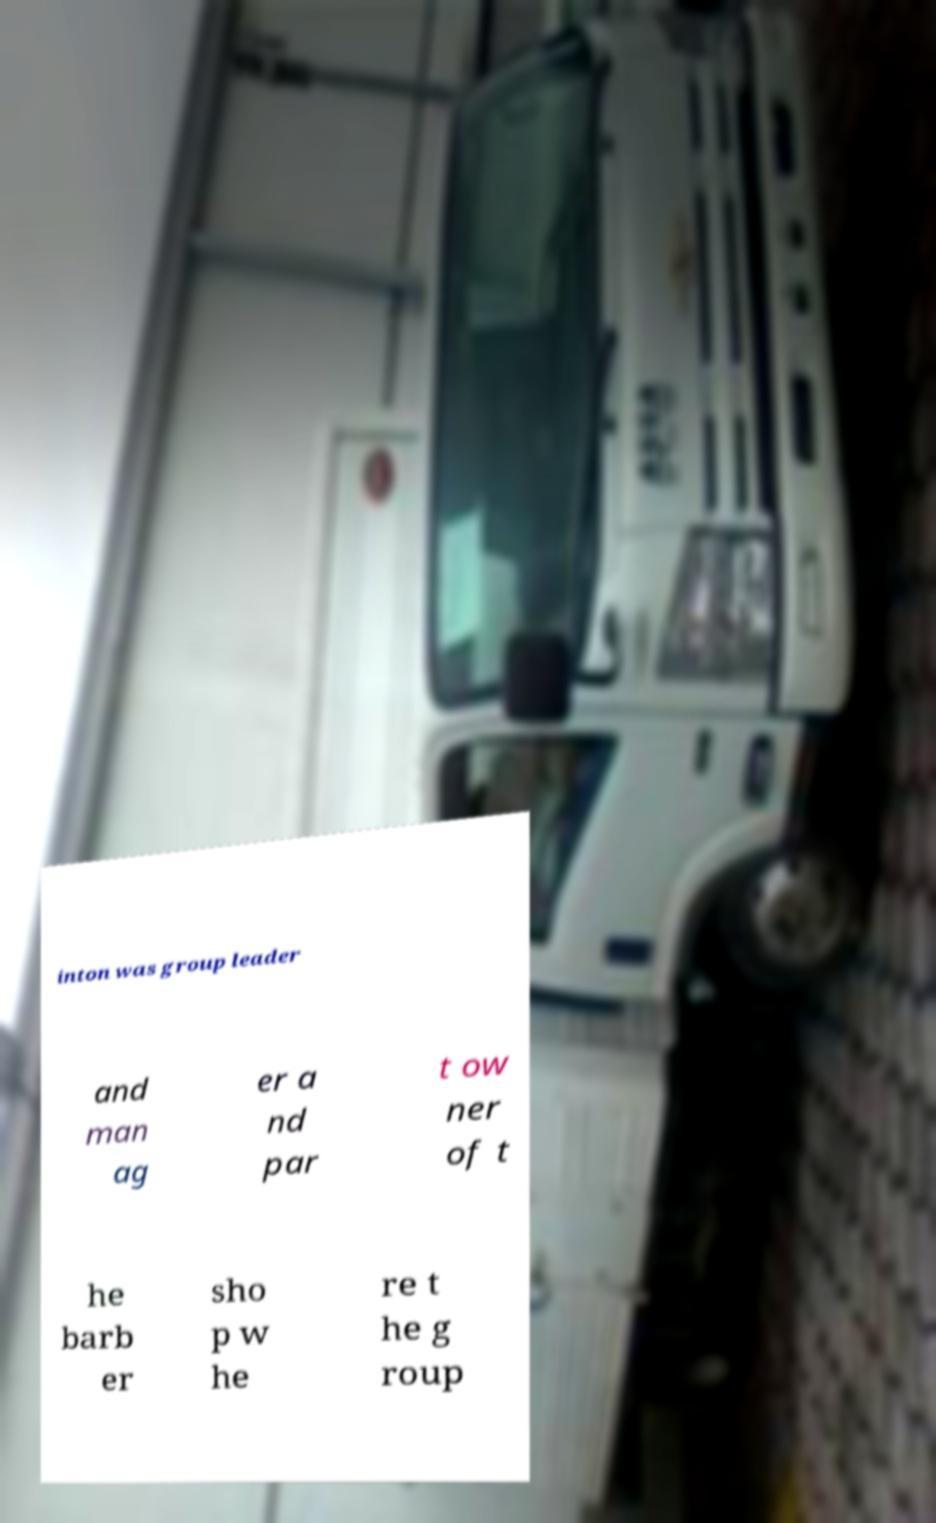There's text embedded in this image that I need extracted. Can you transcribe it verbatim? inton was group leader and man ag er a nd par t ow ner of t he barb er sho p w he re t he g roup 